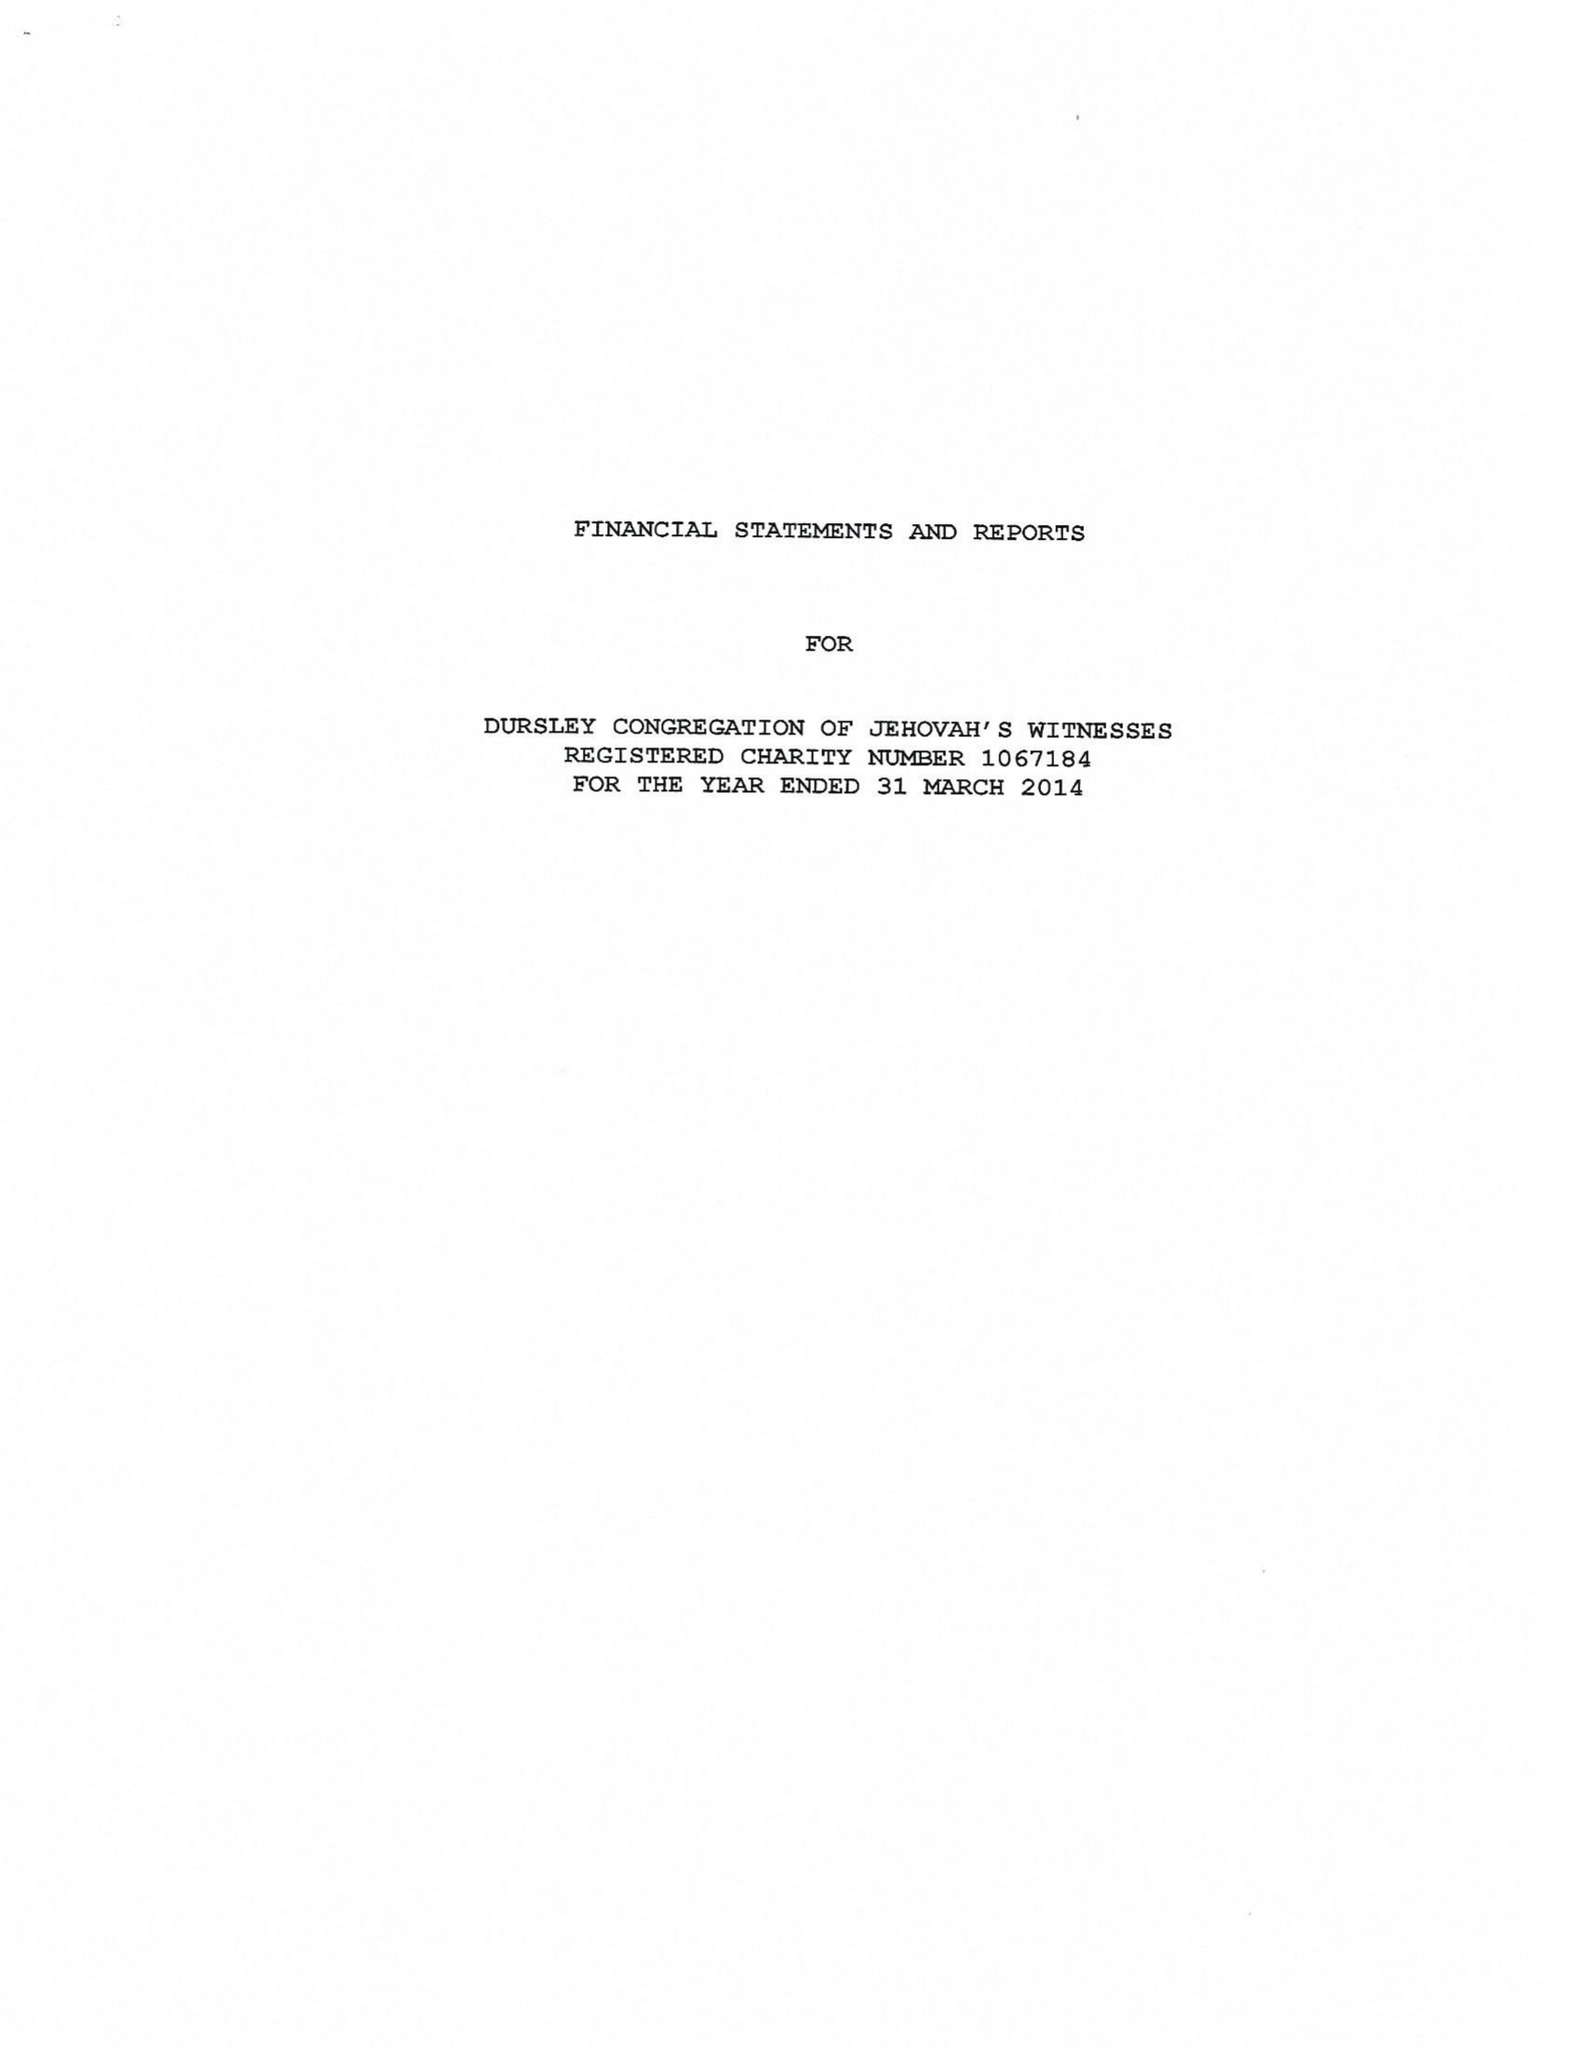What is the value for the charity_name?
Answer the question using a single word or phrase. Dursley Congregation Of Jehovah's Witnesses 